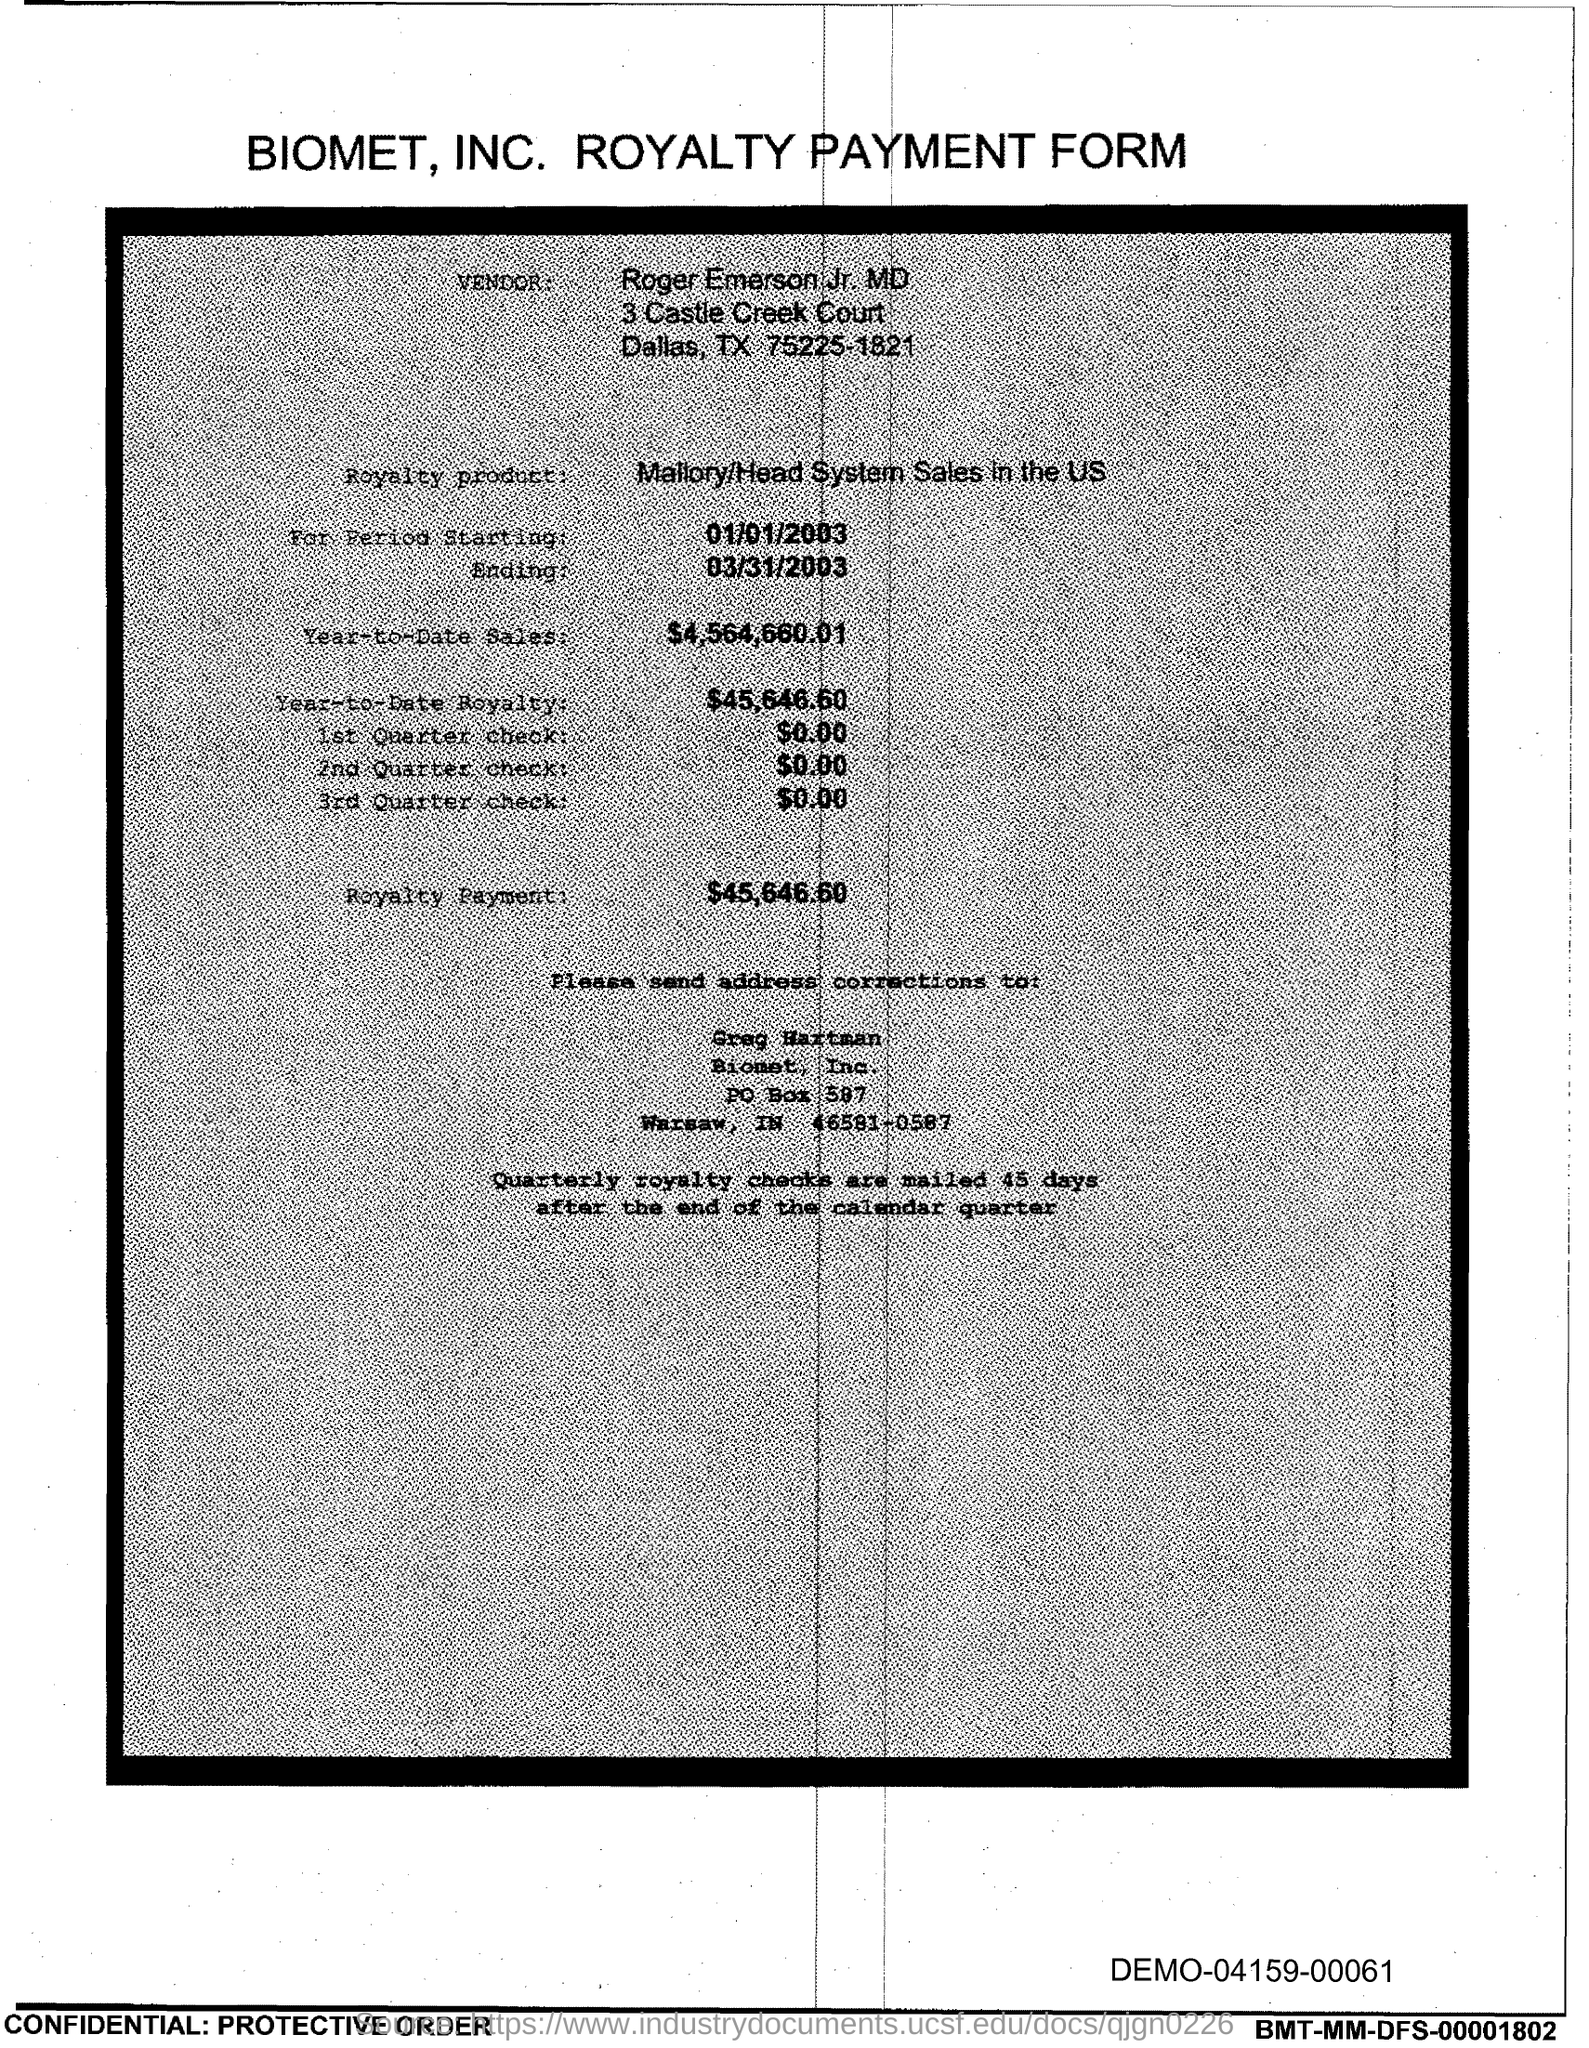What is the vendor name given in the form?
Keep it short and to the point. Roger Emerson Jr. MD. What is the royalty product given in the form?
Provide a short and direct response. Mallory/Head System Sales in the US. What is the start date of the royalty period?
Provide a succinct answer. 01/01/2003. What is the end date of the royalty period?
Ensure brevity in your answer.  03/31/2003. What is the Year-to-Date Sales of the royalty product?
Your response must be concise. $4,564,660.01. What is the Year-to-Date royalty of the product?
Give a very brief answer. $45,646.60. What is the amount of 1st quarter check mentioned in the form?
Your response must be concise. $0.00. What is the amount of 2nd Quarter check mentioned in the form?
Your answer should be very brief. $0.00. What is the royalty payment of the product mentioned in the form?
Give a very brief answer. $45,646.60. 